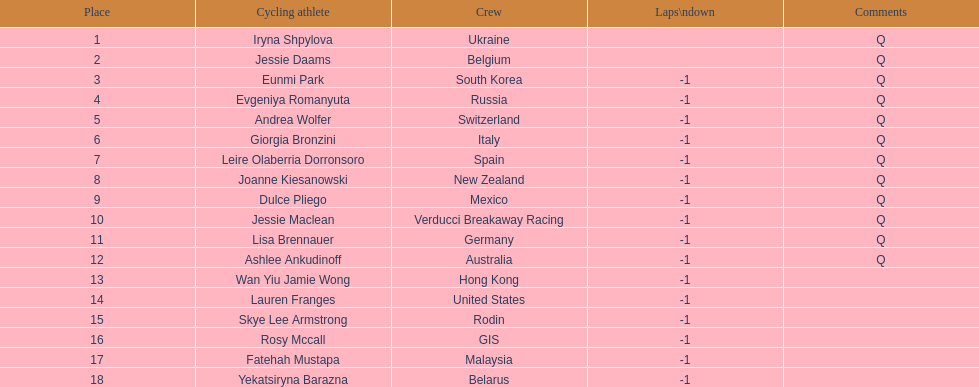How many cyclist are not listed with a country team? 3. 